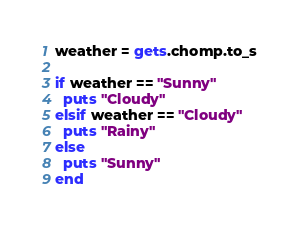Convert code to text. <code><loc_0><loc_0><loc_500><loc_500><_Ruby_>weather = gets.chomp.to_s

if weather == "Sunny"
  puts "Cloudy"
elsif weather == "Cloudy"
  puts "Rainy"
else
  puts "Sunny"
end</code> 